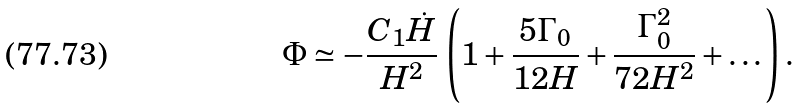<formula> <loc_0><loc_0><loc_500><loc_500>\Phi \simeq - \frac { C _ { 1 } \dot { H } } { H ^ { 2 } } \, \left ( 1 + \frac { 5 \Gamma _ { 0 } } { 1 2 H } + \frac { \Gamma _ { 0 } ^ { 2 } } { 7 2 H ^ { 2 } } + \dots \right ) .</formula> 